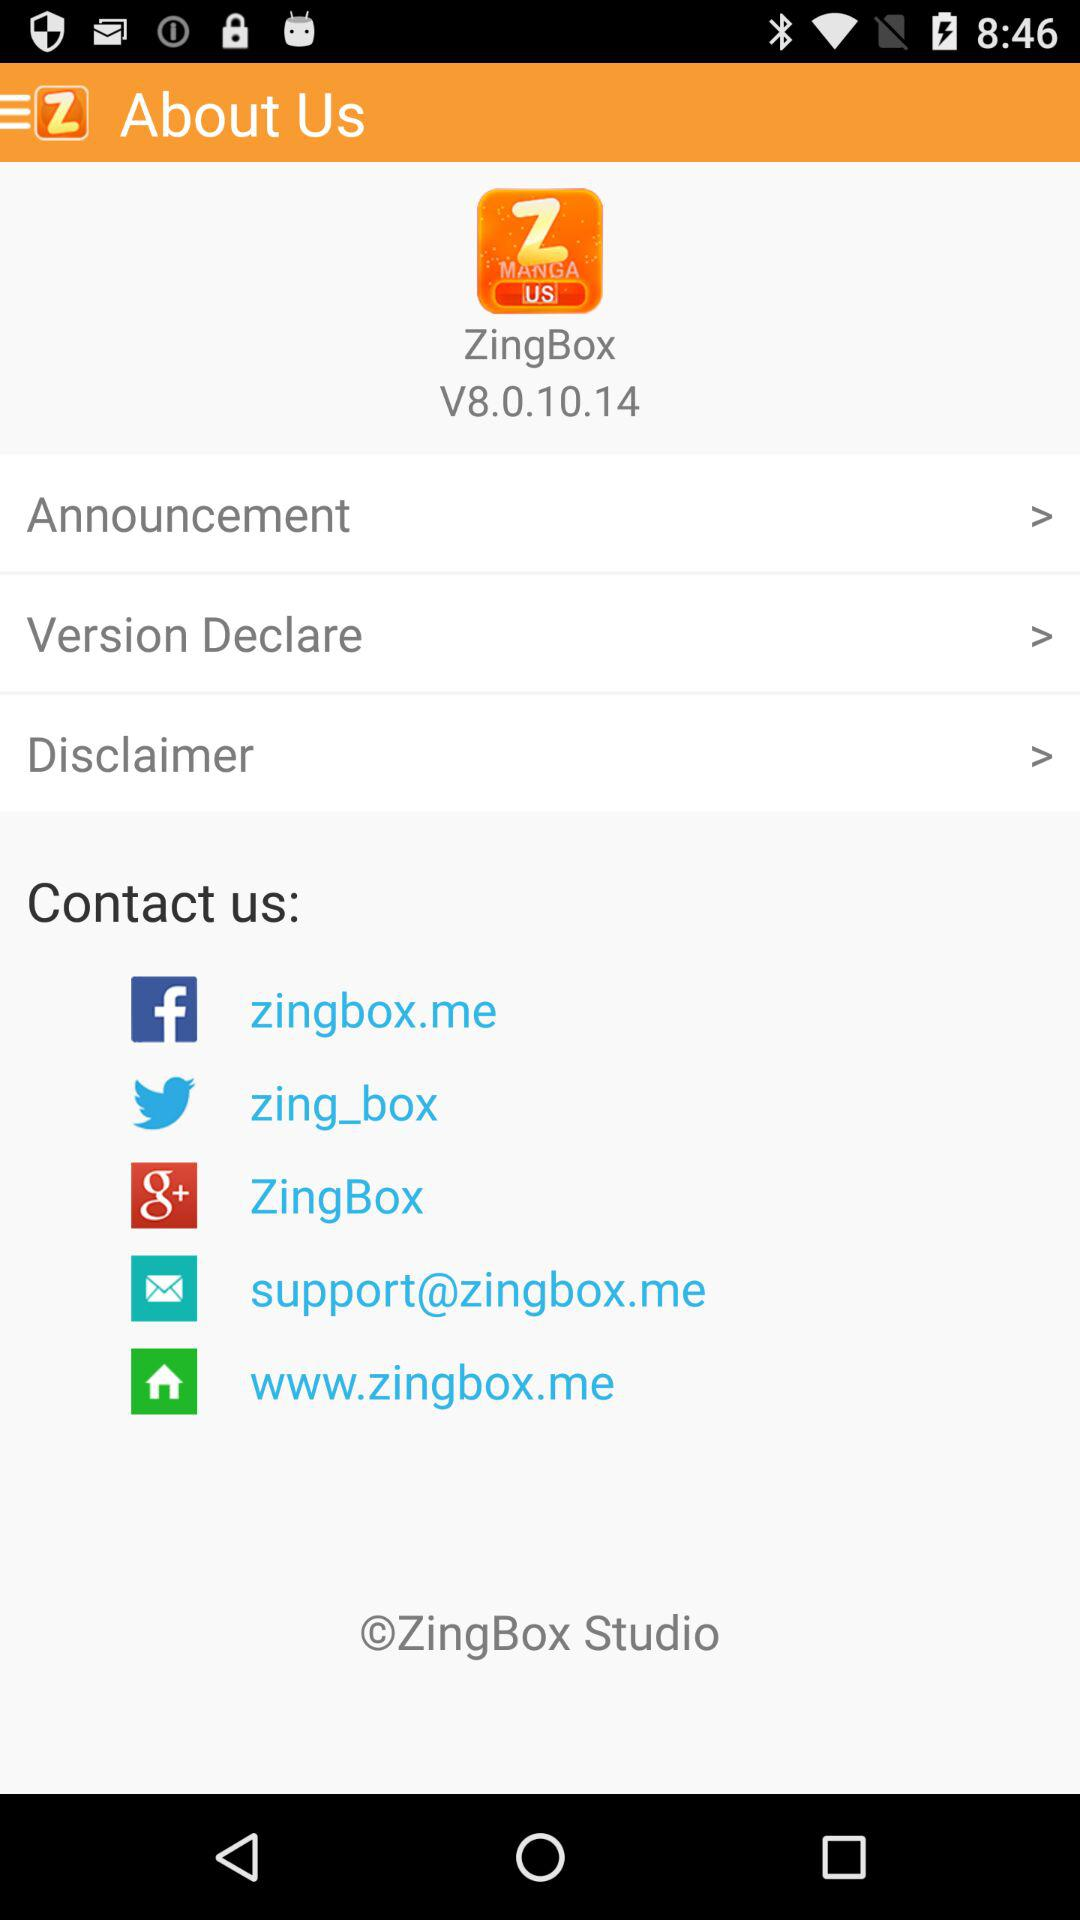What accounts can I use to contact us? You can contact us through "Facebook", "Twitter", "Google+" and "Email". 